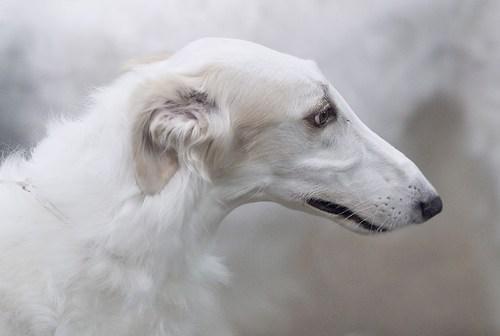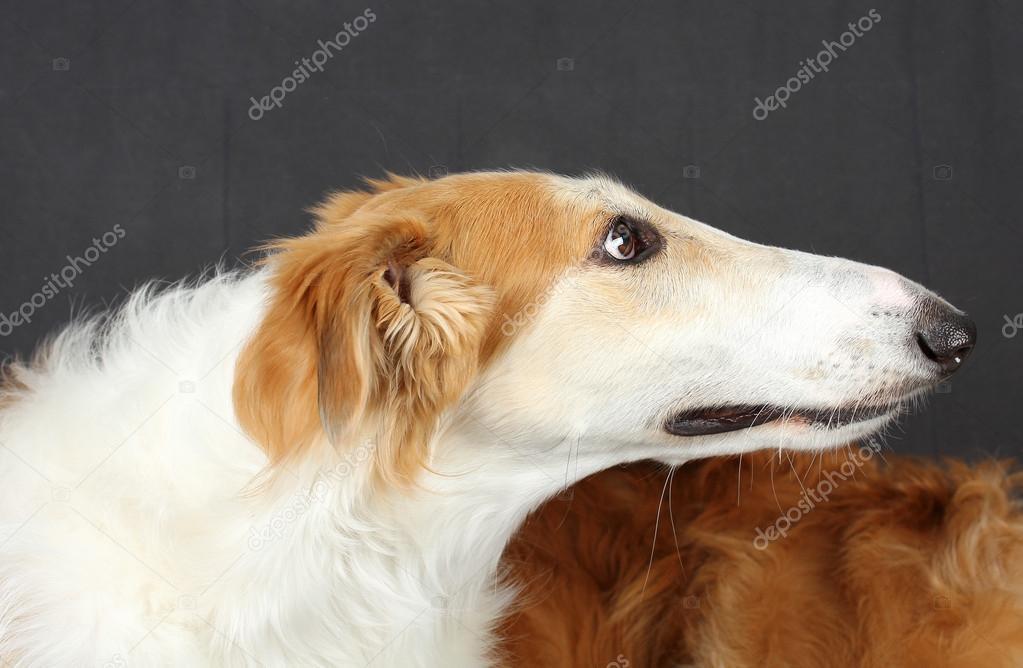The first image is the image on the left, the second image is the image on the right. Considering the images on both sides, is "A single large dog is standing upright in each image." valid? Answer yes or no. No. The first image is the image on the left, the second image is the image on the right. For the images displayed, is the sentence "All images show one hound standing in profile on grass." factually correct? Answer yes or no. No. 